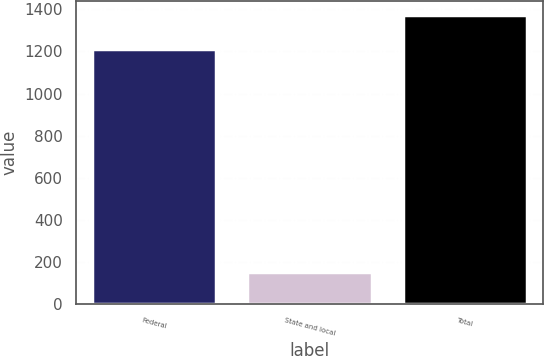<chart> <loc_0><loc_0><loc_500><loc_500><bar_chart><fcel>Federal<fcel>State and local<fcel>Total<nl><fcel>1210<fcel>152<fcel>1372<nl></chart> 